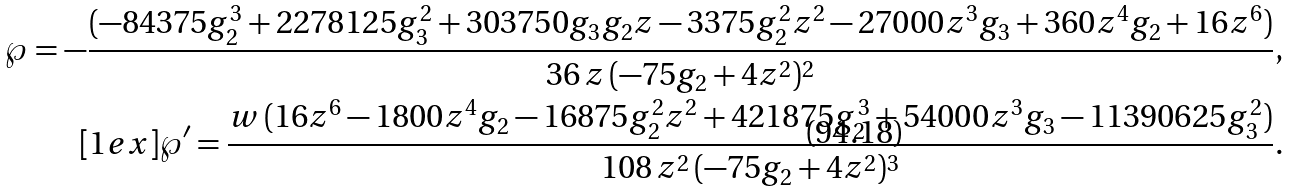Convert formula to latex. <formula><loc_0><loc_0><loc_500><loc_500>\wp = - \frac { ( - 8 4 3 7 5 g _ { 2 } ^ { 3 } + 2 2 7 8 1 2 5 g _ { 3 } ^ { 2 } + 3 0 3 7 5 0 g _ { 3 } g _ { 2 } z - 3 3 7 5 g _ { 2 } ^ { 2 } z ^ { 2 } - 2 7 0 0 0 z ^ { 3 } g _ { 3 } + 3 6 0 z ^ { 4 } g _ { 2 } + 1 6 z ^ { 6 } ) } { 3 6 \, z \, ( - 7 5 g _ { 2 } + 4 z ^ { 2 } ) ^ { 2 } } , \\ [ 1 e x ] \wp ^ { \prime } = \frac { w \, ( 1 6 z ^ { 6 } - 1 8 0 0 z ^ { 4 } g _ { 2 } - 1 6 8 7 5 g _ { 2 } ^ { 2 } z ^ { 2 } + 4 2 1 8 7 5 g _ { 2 } ^ { 3 } + 5 4 0 0 0 z ^ { 3 } g _ { 3 } - 1 1 3 9 0 6 2 5 g _ { 3 } ^ { 2 } ) } { 1 0 8 \, z ^ { 2 } \, ( - 7 5 g _ { 2 } + 4 z ^ { 2 } ) ^ { 3 } } .</formula> 